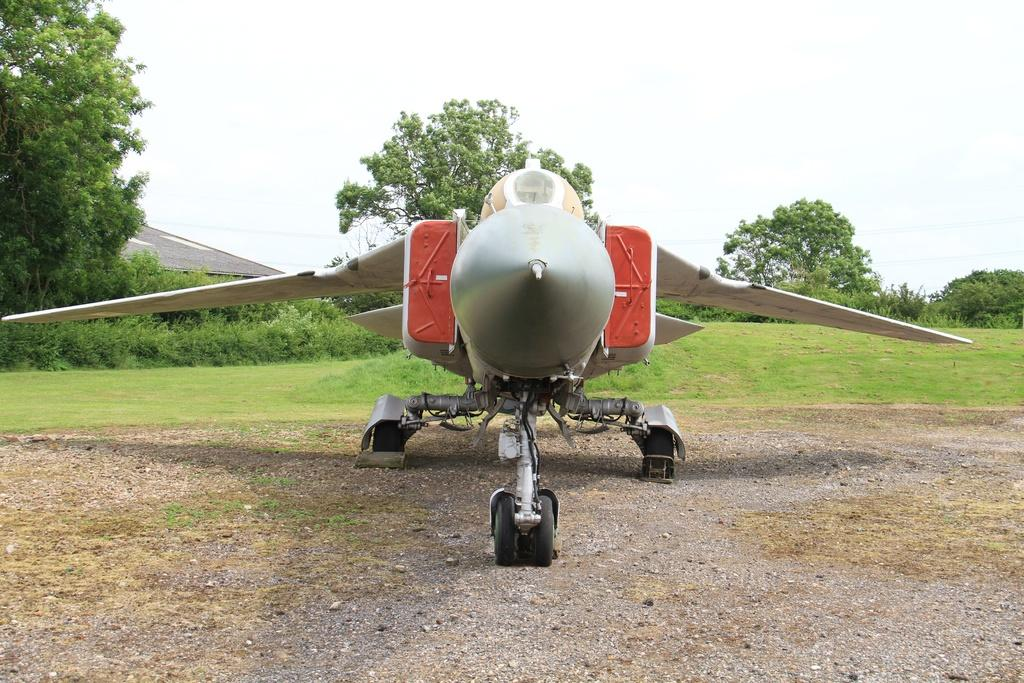What is the main subject of the image? The main subject of the image is an aircraft. What is the current state of the aircraft? The aircraft is parked. What type of natural environment is visible in the image? There is grass, trees, and plants visible in the image. What is visible in the background of the image? The sky is visible in the image. How many deer can be seen grazing near the aircraft in the image? There are no deer present in the image; it only features an aircraft, grass, trees, plants, and the sky. 